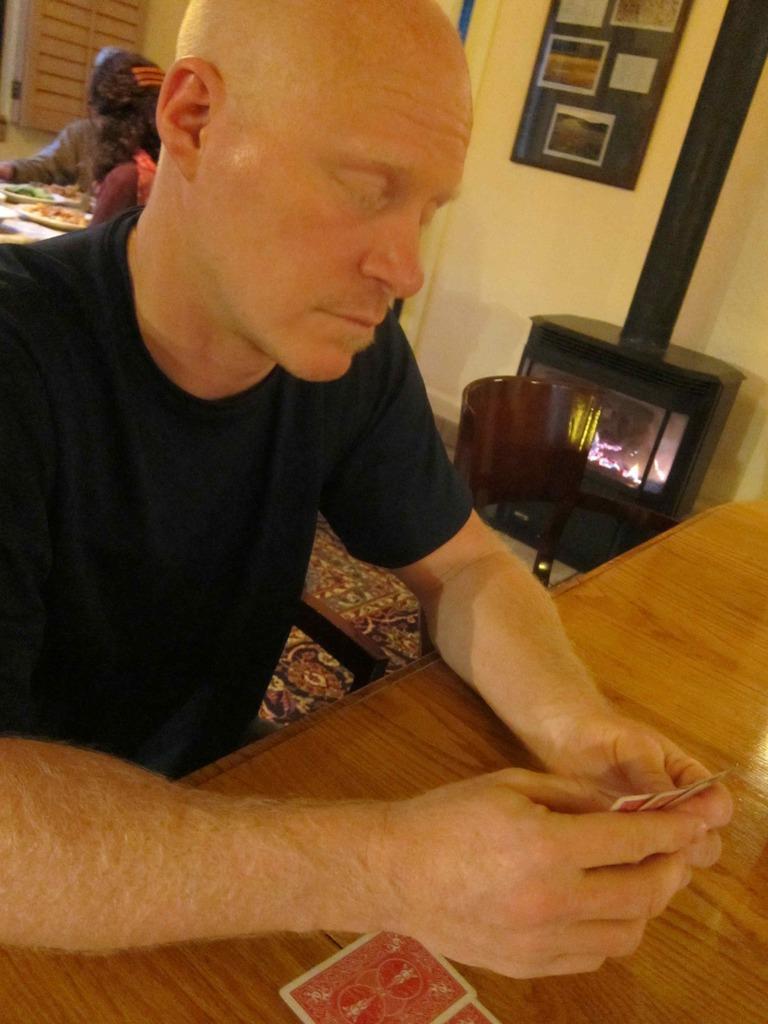In one or two sentences, can you explain what this image depicts? In this image we can see the persons sitting on the chairs and we can see the other person holding the cards. And there are plates with some food items on the table. At the back we can see the wall with photo frames. In front of the wall we can see the black color object with light. 